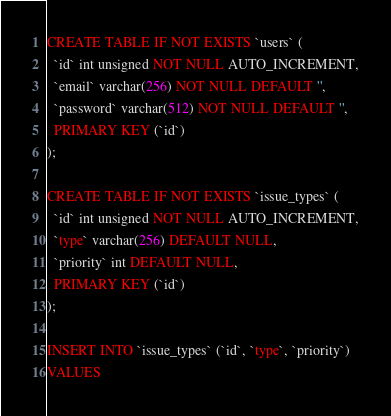Convert code to text. <code><loc_0><loc_0><loc_500><loc_500><_SQL_>CREATE TABLE IF NOT EXISTS `users` (
  `id` int unsigned NOT NULL AUTO_INCREMENT,
  `email` varchar(256) NOT NULL DEFAULT '',
  `password` varchar(512) NOT NULL DEFAULT '',
  PRIMARY KEY (`id`)
);

CREATE TABLE IF NOT EXISTS `issue_types` (
  `id` int unsigned NOT NULL AUTO_INCREMENT,
  `type` varchar(256) DEFAULT NULL,
  `priority` int DEFAULT NULL,
  PRIMARY KEY (`id`)
);

INSERT INTO `issue_types` (`id`, `type`, `priority`)
VALUES</code> 